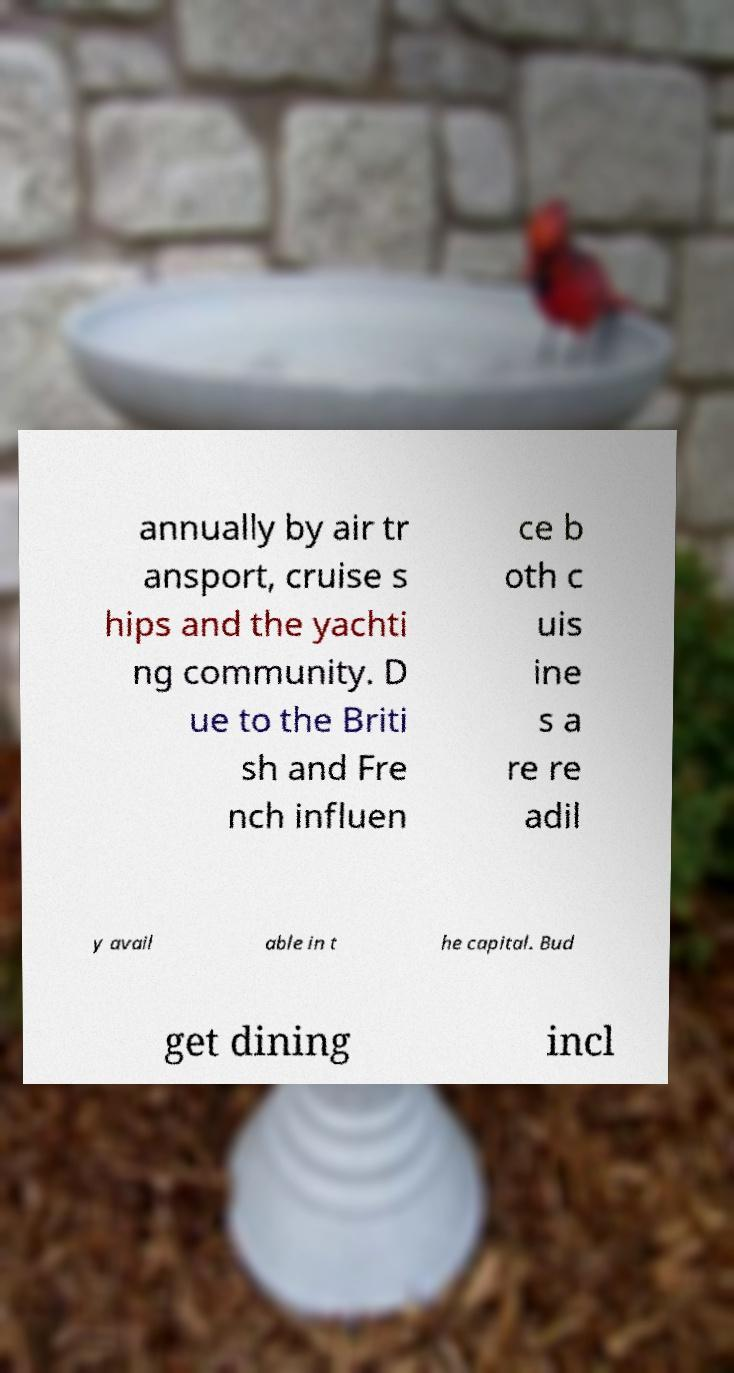Could you assist in decoding the text presented in this image and type it out clearly? annually by air tr ansport, cruise s hips and the yachti ng community. D ue to the Briti sh and Fre nch influen ce b oth c uis ine s a re re adil y avail able in t he capital. Bud get dining incl 